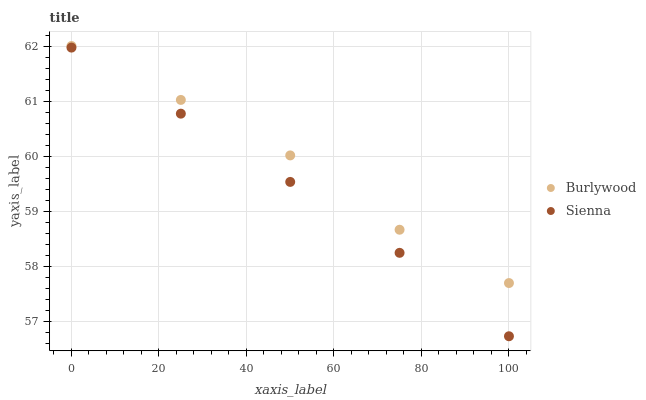Does Sienna have the minimum area under the curve?
Answer yes or no. Yes. Does Burlywood have the maximum area under the curve?
Answer yes or no. Yes. Does Sienna have the maximum area under the curve?
Answer yes or no. No. Is Sienna the smoothest?
Answer yes or no. Yes. Is Burlywood the roughest?
Answer yes or no. Yes. Is Sienna the roughest?
Answer yes or no. No. Does Sienna have the lowest value?
Answer yes or no. Yes. Does Burlywood have the highest value?
Answer yes or no. Yes. Does Sienna have the highest value?
Answer yes or no. No. Is Sienna less than Burlywood?
Answer yes or no. Yes. Is Burlywood greater than Sienna?
Answer yes or no. Yes. Does Sienna intersect Burlywood?
Answer yes or no. No. 